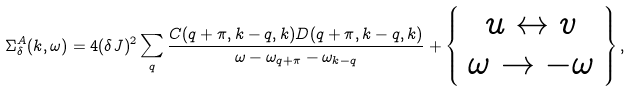Convert formula to latex. <formula><loc_0><loc_0><loc_500><loc_500>\Sigma _ { \delta } ^ { A } ( k , \omega ) = 4 ( \delta J ) ^ { 2 } \sum _ { q } \frac { C ( q + \pi , k - q , k ) D ( q + \pi , k - q , k ) } { \omega - \omega _ { q + \pi } - \omega _ { k - q } } + \left \{ \begin{array} { c } u \leftrightarrow v \\ \omega \rightarrow - \omega \end{array} \right \} ,</formula> 